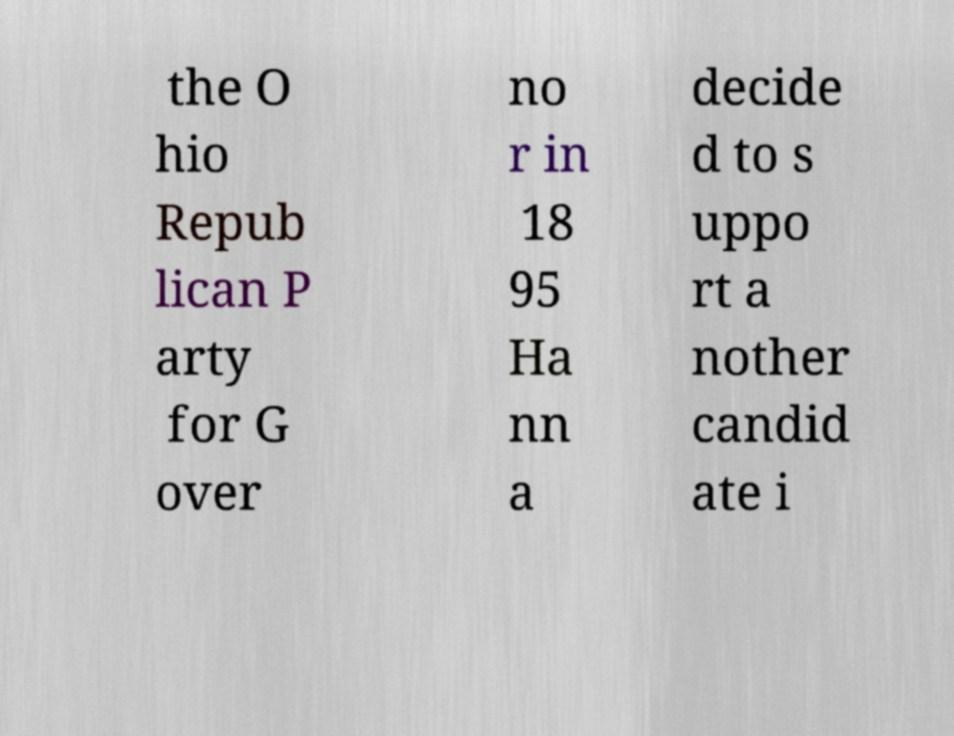I need the written content from this picture converted into text. Can you do that? the O hio Repub lican P arty for G over no r in 18 95 Ha nn a decide d to s uppo rt a nother candid ate i 